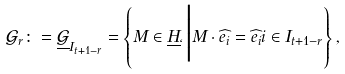Convert formula to latex. <formula><loc_0><loc_0><loc_500><loc_500>\mathcal { G } _ { r } \colon = \underline { \mathcal { G } } _ { I _ { t + 1 - r } } = \left \{ M \in \underline { H } _ { \ell } \Big | M \cdot \widehat { e _ { i } } = \widehat { e _ { i } } i \in I _ { t + 1 - r } \right \} ,</formula> 